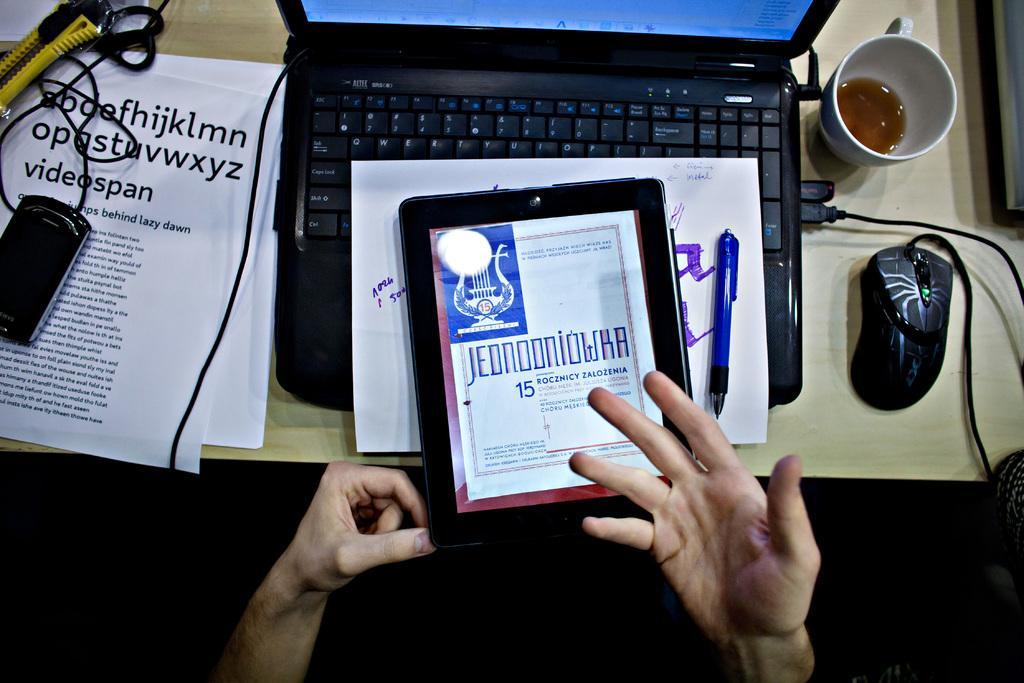In one or two sentences, can you explain what this image depicts? In this image we can see a person's hand. Here we can see tablet, paper, pen, laptop opened, mouse, cup, mobile phone, papers, wires and scissors are placed on the wooden table. Here we can see the image is dark. 